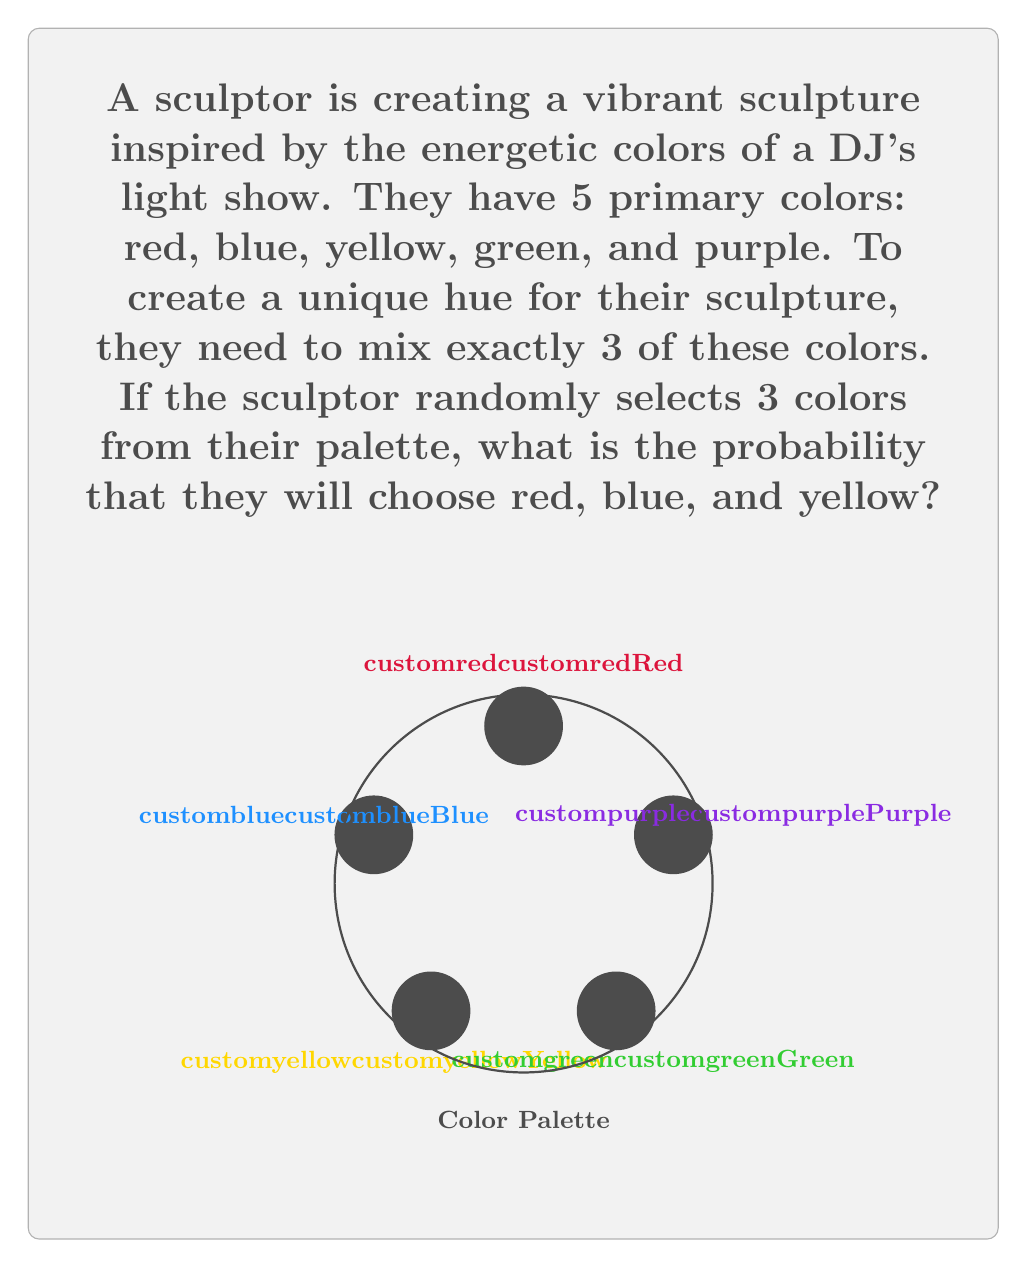Give your solution to this math problem. Let's approach this step-by-step:

1) First, we need to calculate the total number of ways to choose 3 colors from 5 colors. This is a combination problem, denoted as $\binom{5}{3}$ or $C(5,3)$.

2) The formula for this combination is:

   $$\binom{5}{3} = \frac{5!}{3!(5-3)!} = \frac{5!}{3!2!}$$

3) Let's calculate this:
   $$\frac{5 \cdot 4 \cdot 3!}{3! \cdot 2 \cdot 1} = \frac{5 \cdot 4}{2 \cdot 1} = \frac{20}{2} = 10$$

4) So there are 10 possible ways to choose 3 colors from 5 colors.

5) Now, we're interested in only one specific combination: red, blue, and yellow. There's only one way to choose this exact combination.

6) The probability is therefore:

   $$P(\text{red, blue, yellow}) = \frac{\text{favorable outcomes}}{\text{total outcomes}} = \frac{1}{10}$$

Thus, the probability of randomly selecting red, blue, and yellow is $\frac{1}{10}$ or 0.1 or 10%.
Answer: $\frac{1}{10}$ 